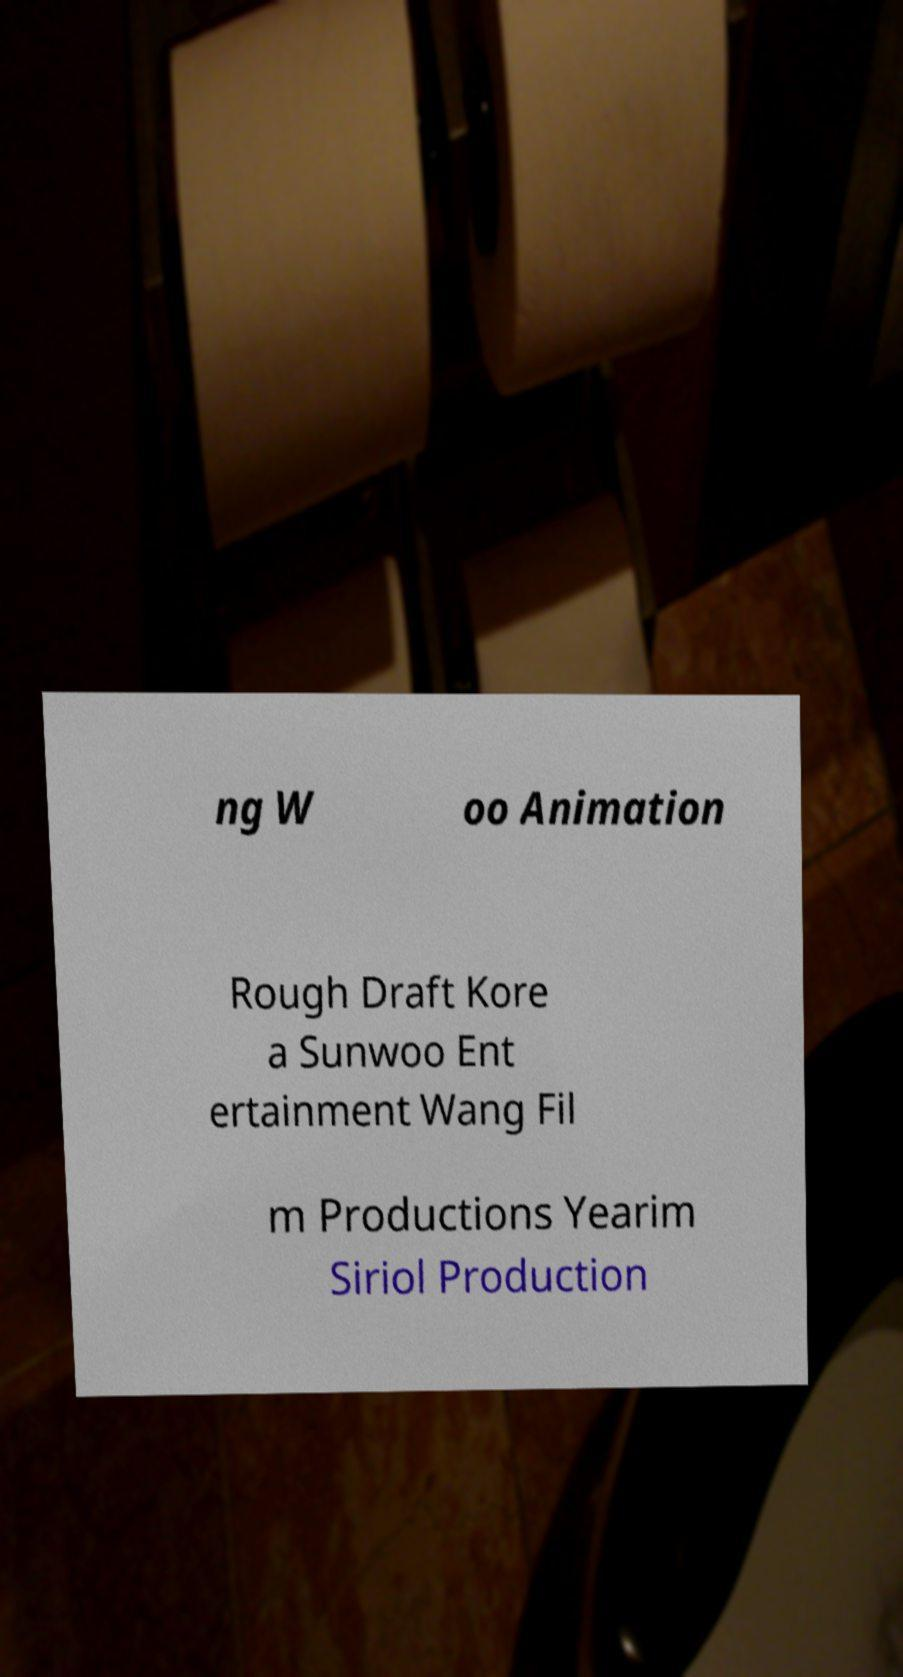Could you assist in decoding the text presented in this image and type it out clearly? ng W oo Animation Rough Draft Kore a Sunwoo Ent ertainment Wang Fil m Productions Yearim Siriol Production 